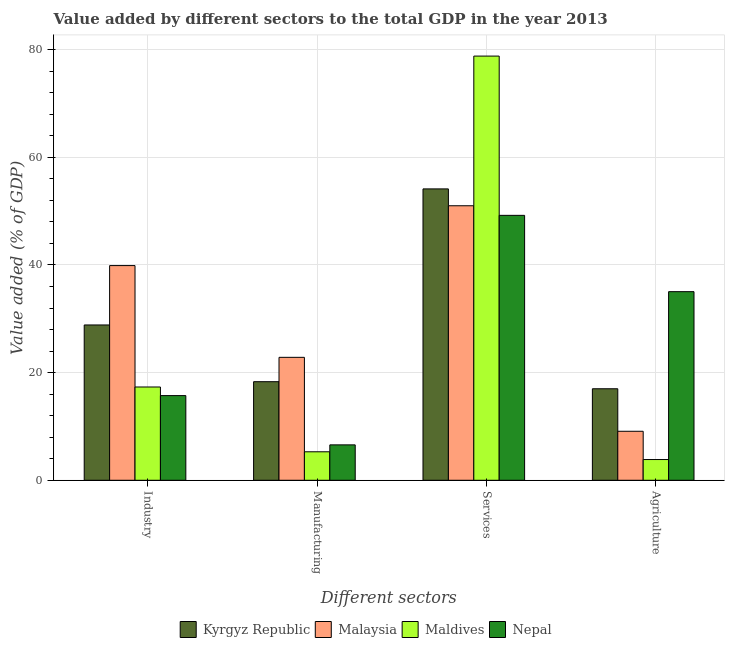How many groups of bars are there?
Provide a short and direct response. 4. Are the number of bars on each tick of the X-axis equal?
Give a very brief answer. Yes. What is the label of the 1st group of bars from the left?
Make the answer very short. Industry. What is the value added by services sector in Maldives?
Provide a succinct answer. 78.82. Across all countries, what is the maximum value added by industrial sector?
Your answer should be compact. 39.89. Across all countries, what is the minimum value added by industrial sector?
Offer a terse response. 15.73. In which country was the value added by agricultural sector maximum?
Your answer should be compact. Nepal. In which country was the value added by agricultural sector minimum?
Your response must be concise. Maldives. What is the total value added by industrial sector in the graph?
Provide a succinct answer. 101.81. What is the difference between the value added by services sector in Maldives and that in Nepal?
Offer a terse response. 29.59. What is the difference between the value added by industrial sector in Maldives and the value added by services sector in Nepal?
Your answer should be very brief. -31.89. What is the average value added by manufacturing sector per country?
Offer a very short reply. 13.26. What is the difference between the value added by industrial sector and value added by services sector in Maldives?
Give a very brief answer. -61.49. What is the ratio of the value added by services sector in Malaysia to that in Maldives?
Ensure brevity in your answer.  0.65. Is the difference between the value added by agricultural sector in Nepal and Malaysia greater than the difference between the value added by industrial sector in Nepal and Malaysia?
Give a very brief answer. Yes. What is the difference between the highest and the second highest value added by services sector?
Your answer should be compact. 24.68. What is the difference between the highest and the lowest value added by services sector?
Your answer should be very brief. 29.59. In how many countries, is the value added by industrial sector greater than the average value added by industrial sector taken over all countries?
Your answer should be compact. 2. Is it the case that in every country, the sum of the value added by agricultural sector and value added by manufacturing sector is greater than the sum of value added by industrial sector and value added by services sector?
Provide a short and direct response. No. What does the 2nd bar from the left in Industry represents?
Ensure brevity in your answer.  Malaysia. What does the 1st bar from the right in Services represents?
Give a very brief answer. Nepal. Is it the case that in every country, the sum of the value added by industrial sector and value added by manufacturing sector is greater than the value added by services sector?
Offer a very short reply. No. How many bars are there?
Your answer should be very brief. 16. Are all the bars in the graph horizontal?
Your answer should be very brief. No. How many countries are there in the graph?
Give a very brief answer. 4. What is the difference between two consecutive major ticks on the Y-axis?
Provide a succinct answer. 20. Are the values on the major ticks of Y-axis written in scientific E-notation?
Your response must be concise. No. Where does the legend appear in the graph?
Keep it short and to the point. Bottom center. How are the legend labels stacked?
Provide a short and direct response. Horizontal. What is the title of the graph?
Provide a short and direct response. Value added by different sectors to the total GDP in the year 2013. Does "South Sudan" appear as one of the legend labels in the graph?
Offer a terse response. No. What is the label or title of the X-axis?
Your response must be concise. Different sectors. What is the label or title of the Y-axis?
Make the answer very short. Value added (% of GDP). What is the Value added (% of GDP) of Kyrgyz Republic in Industry?
Offer a very short reply. 28.86. What is the Value added (% of GDP) of Malaysia in Industry?
Ensure brevity in your answer.  39.89. What is the Value added (% of GDP) in Maldives in Industry?
Your response must be concise. 17.33. What is the Value added (% of GDP) in Nepal in Industry?
Offer a very short reply. 15.73. What is the Value added (% of GDP) in Kyrgyz Republic in Manufacturing?
Your response must be concise. 18.32. What is the Value added (% of GDP) of Malaysia in Manufacturing?
Your answer should be compact. 22.84. What is the Value added (% of GDP) in Maldives in Manufacturing?
Your response must be concise. 5.29. What is the Value added (% of GDP) in Nepal in Manufacturing?
Provide a short and direct response. 6.58. What is the Value added (% of GDP) of Kyrgyz Republic in Services?
Give a very brief answer. 54.14. What is the Value added (% of GDP) in Malaysia in Services?
Offer a terse response. 51.01. What is the Value added (% of GDP) of Maldives in Services?
Keep it short and to the point. 78.82. What is the Value added (% of GDP) in Nepal in Services?
Provide a short and direct response. 49.22. What is the Value added (% of GDP) of Kyrgyz Republic in Agriculture?
Ensure brevity in your answer.  17. What is the Value added (% of GDP) of Malaysia in Agriculture?
Your response must be concise. 9.1. What is the Value added (% of GDP) of Maldives in Agriculture?
Ensure brevity in your answer.  3.85. What is the Value added (% of GDP) of Nepal in Agriculture?
Your answer should be compact. 35.05. Across all Different sectors, what is the maximum Value added (% of GDP) of Kyrgyz Republic?
Provide a short and direct response. 54.14. Across all Different sectors, what is the maximum Value added (% of GDP) in Malaysia?
Provide a succinct answer. 51.01. Across all Different sectors, what is the maximum Value added (% of GDP) in Maldives?
Provide a short and direct response. 78.82. Across all Different sectors, what is the maximum Value added (% of GDP) in Nepal?
Ensure brevity in your answer.  49.22. Across all Different sectors, what is the minimum Value added (% of GDP) in Kyrgyz Republic?
Offer a terse response. 17. Across all Different sectors, what is the minimum Value added (% of GDP) of Malaysia?
Provide a short and direct response. 9.1. Across all Different sectors, what is the minimum Value added (% of GDP) in Maldives?
Make the answer very short. 3.85. Across all Different sectors, what is the minimum Value added (% of GDP) in Nepal?
Give a very brief answer. 6.58. What is the total Value added (% of GDP) in Kyrgyz Republic in the graph?
Provide a succinct answer. 118.32. What is the total Value added (% of GDP) in Malaysia in the graph?
Provide a succinct answer. 122.84. What is the total Value added (% of GDP) in Maldives in the graph?
Keep it short and to the point. 105.29. What is the total Value added (% of GDP) of Nepal in the graph?
Your answer should be very brief. 106.58. What is the difference between the Value added (% of GDP) in Kyrgyz Republic in Industry and that in Manufacturing?
Make the answer very short. 10.54. What is the difference between the Value added (% of GDP) of Malaysia in Industry and that in Manufacturing?
Provide a succinct answer. 17.05. What is the difference between the Value added (% of GDP) of Maldives in Industry and that in Manufacturing?
Your response must be concise. 12.04. What is the difference between the Value added (% of GDP) of Nepal in Industry and that in Manufacturing?
Offer a terse response. 9.15. What is the difference between the Value added (% of GDP) of Kyrgyz Republic in Industry and that in Services?
Give a very brief answer. -25.28. What is the difference between the Value added (% of GDP) of Malaysia in Industry and that in Services?
Your response must be concise. -11.12. What is the difference between the Value added (% of GDP) of Maldives in Industry and that in Services?
Your answer should be very brief. -61.49. What is the difference between the Value added (% of GDP) in Nepal in Industry and that in Services?
Provide a succinct answer. -33.49. What is the difference between the Value added (% of GDP) of Kyrgyz Republic in Industry and that in Agriculture?
Your response must be concise. 11.85. What is the difference between the Value added (% of GDP) of Malaysia in Industry and that in Agriculture?
Offer a very short reply. 30.78. What is the difference between the Value added (% of GDP) of Maldives in Industry and that in Agriculture?
Keep it short and to the point. 13.48. What is the difference between the Value added (% of GDP) of Nepal in Industry and that in Agriculture?
Provide a short and direct response. -19.31. What is the difference between the Value added (% of GDP) of Kyrgyz Republic in Manufacturing and that in Services?
Make the answer very short. -35.82. What is the difference between the Value added (% of GDP) of Malaysia in Manufacturing and that in Services?
Your answer should be compact. -28.17. What is the difference between the Value added (% of GDP) in Maldives in Manufacturing and that in Services?
Offer a very short reply. -73.53. What is the difference between the Value added (% of GDP) of Nepal in Manufacturing and that in Services?
Make the answer very short. -42.65. What is the difference between the Value added (% of GDP) of Kyrgyz Republic in Manufacturing and that in Agriculture?
Give a very brief answer. 1.31. What is the difference between the Value added (% of GDP) of Malaysia in Manufacturing and that in Agriculture?
Offer a very short reply. 13.74. What is the difference between the Value added (% of GDP) of Maldives in Manufacturing and that in Agriculture?
Provide a short and direct response. 1.44. What is the difference between the Value added (% of GDP) in Nepal in Manufacturing and that in Agriculture?
Your answer should be very brief. -28.47. What is the difference between the Value added (% of GDP) of Kyrgyz Republic in Services and that in Agriculture?
Your response must be concise. 37.14. What is the difference between the Value added (% of GDP) of Malaysia in Services and that in Agriculture?
Offer a terse response. 41.9. What is the difference between the Value added (% of GDP) of Maldives in Services and that in Agriculture?
Ensure brevity in your answer.  74.97. What is the difference between the Value added (% of GDP) in Nepal in Services and that in Agriculture?
Your response must be concise. 14.18. What is the difference between the Value added (% of GDP) of Kyrgyz Republic in Industry and the Value added (% of GDP) of Malaysia in Manufacturing?
Ensure brevity in your answer.  6.01. What is the difference between the Value added (% of GDP) of Kyrgyz Republic in Industry and the Value added (% of GDP) of Maldives in Manufacturing?
Offer a very short reply. 23.57. What is the difference between the Value added (% of GDP) of Kyrgyz Republic in Industry and the Value added (% of GDP) of Nepal in Manufacturing?
Offer a terse response. 22.28. What is the difference between the Value added (% of GDP) of Malaysia in Industry and the Value added (% of GDP) of Maldives in Manufacturing?
Ensure brevity in your answer.  34.6. What is the difference between the Value added (% of GDP) in Malaysia in Industry and the Value added (% of GDP) in Nepal in Manufacturing?
Provide a short and direct response. 33.31. What is the difference between the Value added (% of GDP) in Maldives in Industry and the Value added (% of GDP) in Nepal in Manufacturing?
Offer a terse response. 10.75. What is the difference between the Value added (% of GDP) in Kyrgyz Republic in Industry and the Value added (% of GDP) in Malaysia in Services?
Make the answer very short. -22.15. What is the difference between the Value added (% of GDP) in Kyrgyz Republic in Industry and the Value added (% of GDP) in Maldives in Services?
Offer a terse response. -49.96. What is the difference between the Value added (% of GDP) in Kyrgyz Republic in Industry and the Value added (% of GDP) in Nepal in Services?
Ensure brevity in your answer.  -20.37. What is the difference between the Value added (% of GDP) of Malaysia in Industry and the Value added (% of GDP) of Maldives in Services?
Ensure brevity in your answer.  -38.93. What is the difference between the Value added (% of GDP) in Malaysia in Industry and the Value added (% of GDP) in Nepal in Services?
Your response must be concise. -9.34. What is the difference between the Value added (% of GDP) in Maldives in Industry and the Value added (% of GDP) in Nepal in Services?
Offer a terse response. -31.89. What is the difference between the Value added (% of GDP) of Kyrgyz Republic in Industry and the Value added (% of GDP) of Malaysia in Agriculture?
Ensure brevity in your answer.  19.75. What is the difference between the Value added (% of GDP) of Kyrgyz Republic in Industry and the Value added (% of GDP) of Maldives in Agriculture?
Offer a terse response. 25.01. What is the difference between the Value added (% of GDP) in Kyrgyz Republic in Industry and the Value added (% of GDP) in Nepal in Agriculture?
Keep it short and to the point. -6.19. What is the difference between the Value added (% of GDP) of Malaysia in Industry and the Value added (% of GDP) of Maldives in Agriculture?
Give a very brief answer. 36.04. What is the difference between the Value added (% of GDP) in Malaysia in Industry and the Value added (% of GDP) in Nepal in Agriculture?
Your answer should be very brief. 4.84. What is the difference between the Value added (% of GDP) in Maldives in Industry and the Value added (% of GDP) in Nepal in Agriculture?
Your answer should be compact. -17.71. What is the difference between the Value added (% of GDP) of Kyrgyz Republic in Manufacturing and the Value added (% of GDP) of Malaysia in Services?
Ensure brevity in your answer.  -32.69. What is the difference between the Value added (% of GDP) of Kyrgyz Republic in Manufacturing and the Value added (% of GDP) of Maldives in Services?
Your answer should be very brief. -60.5. What is the difference between the Value added (% of GDP) of Kyrgyz Republic in Manufacturing and the Value added (% of GDP) of Nepal in Services?
Provide a succinct answer. -30.91. What is the difference between the Value added (% of GDP) of Malaysia in Manufacturing and the Value added (% of GDP) of Maldives in Services?
Offer a terse response. -55.98. What is the difference between the Value added (% of GDP) of Malaysia in Manufacturing and the Value added (% of GDP) of Nepal in Services?
Offer a terse response. -26.38. What is the difference between the Value added (% of GDP) in Maldives in Manufacturing and the Value added (% of GDP) in Nepal in Services?
Provide a succinct answer. -43.93. What is the difference between the Value added (% of GDP) in Kyrgyz Republic in Manufacturing and the Value added (% of GDP) in Malaysia in Agriculture?
Give a very brief answer. 9.21. What is the difference between the Value added (% of GDP) of Kyrgyz Republic in Manufacturing and the Value added (% of GDP) of Maldives in Agriculture?
Your answer should be compact. 14.46. What is the difference between the Value added (% of GDP) of Kyrgyz Republic in Manufacturing and the Value added (% of GDP) of Nepal in Agriculture?
Make the answer very short. -16.73. What is the difference between the Value added (% of GDP) of Malaysia in Manufacturing and the Value added (% of GDP) of Maldives in Agriculture?
Your response must be concise. 18.99. What is the difference between the Value added (% of GDP) of Malaysia in Manufacturing and the Value added (% of GDP) of Nepal in Agriculture?
Offer a terse response. -12.2. What is the difference between the Value added (% of GDP) of Maldives in Manufacturing and the Value added (% of GDP) of Nepal in Agriculture?
Provide a succinct answer. -29.75. What is the difference between the Value added (% of GDP) in Kyrgyz Republic in Services and the Value added (% of GDP) in Malaysia in Agriculture?
Offer a very short reply. 45.04. What is the difference between the Value added (% of GDP) in Kyrgyz Republic in Services and the Value added (% of GDP) in Maldives in Agriculture?
Keep it short and to the point. 50.29. What is the difference between the Value added (% of GDP) in Kyrgyz Republic in Services and the Value added (% of GDP) in Nepal in Agriculture?
Ensure brevity in your answer.  19.1. What is the difference between the Value added (% of GDP) of Malaysia in Services and the Value added (% of GDP) of Maldives in Agriculture?
Offer a terse response. 47.16. What is the difference between the Value added (% of GDP) of Malaysia in Services and the Value added (% of GDP) of Nepal in Agriculture?
Provide a short and direct response. 15.96. What is the difference between the Value added (% of GDP) of Maldives in Services and the Value added (% of GDP) of Nepal in Agriculture?
Ensure brevity in your answer.  43.77. What is the average Value added (% of GDP) of Kyrgyz Republic per Different sectors?
Make the answer very short. 29.58. What is the average Value added (% of GDP) in Malaysia per Different sectors?
Keep it short and to the point. 30.71. What is the average Value added (% of GDP) in Maldives per Different sectors?
Provide a short and direct response. 26.32. What is the average Value added (% of GDP) of Nepal per Different sectors?
Make the answer very short. 26.64. What is the difference between the Value added (% of GDP) in Kyrgyz Republic and Value added (% of GDP) in Malaysia in Industry?
Make the answer very short. -11.03. What is the difference between the Value added (% of GDP) in Kyrgyz Republic and Value added (% of GDP) in Maldives in Industry?
Offer a terse response. 11.53. What is the difference between the Value added (% of GDP) in Kyrgyz Republic and Value added (% of GDP) in Nepal in Industry?
Provide a succinct answer. 13.13. What is the difference between the Value added (% of GDP) in Malaysia and Value added (% of GDP) in Maldives in Industry?
Keep it short and to the point. 22.56. What is the difference between the Value added (% of GDP) of Malaysia and Value added (% of GDP) of Nepal in Industry?
Make the answer very short. 24.16. What is the difference between the Value added (% of GDP) of Maldives and Value added (% of GDP) of Nepal in Industry?
Your answer should be compact. 1.6. What is the difference between the Value added (% of GDP) of Kyrgyz Republic and Value added (% of GDP) of Malaysia in Manufacturing?
Offer a very short reply. -4.53. What is the difference between the Value added (% of GDP) of Kyrgyz Republic and Value added (% of GDP) of Maldives in Manufacturing?
Your response must be concise. 13.02. What is the difference between the Value added (% of GDP) of Kyrgyz Republic and Value added (% of GDP) of Nepal in Manufacturing?
Your answer should be very brief. 11.74. What is the difference between the Value added (% of GDP) of Malaysia and Value added (% of GDP) of Maldives in Manufacturing?
Your response must be concise. 17.55. What is the difference between the Value added (% of GDP) in Malaysia and Value added (% of GDP) in Nepal in Manufacturing?
Your answer should be compact. 16.27. What is the difference between the Value added (% of GDP) of Maldives and Value added (% of GDP) of Nepal in Manufacturing?
Keep it short and to the point. -1.29. What is the difference between the Value added (% of GDP) of Kyrgyz Republic and Value added (% of GDP) of Malaysia in Services?
Ensure brevity in your answer.  3.13. What is the difference between the Value added (% of GDP) in Kyrgyz Republic and Value added (% of GDP) in Maldives in Services?
Make the answer very short. -24.68. What is the difference between the Value added (% of GDP) in Kyrgyz Republic and Value added (% of GDP) in Nepal in Services?
Give a very brief answer. 4.92. What is the difference between the Value added (% of GDP) of Malaysia and Value added (% of GDP) of Maldives in Services?
Your answer should be very brief. -27.81. What is the difference between the Value added (% of GDP) in Malaysia and Value added (% of GDP) in Nepal in Services?
Offer a terse response. 1.78. What is the difference between the Value added (% of GDP) of Maldives and Value added (% of GDP) of Nepal in Services?
Offer a very short reply. 29.59. What is the difference between the Value added (% of GDP) in Kyrgyz Republic and Value added (% of GDP) in Malaysia in Agriculture?
Ensure brevity in your answer.  7.9. What is the difference between the Value added (% of GDP) of Kyrgyz Republic and Value added (% of GDP) of Maldives in Agriculture?
Give a very brief answer. 13.15. What is the difference between the Value added (% of GDP) in Kyrgyz Republic and Value added (% of GDP) in Nepal in Agriculture?
Keep it short and to the point. -18.04. What is the difference between the Value added (% of GDP) in Malaysia and Value added (% of GDP) in Maldives in Agriculture?
Keep it short and to the point. 5.25. What is the difference between the Value added (% of GDP) in Malaysia and Value added (% of GDP) in Nepal in Agriculture?
Offer a very short reply. -25.94. What is the difference between the Value added (% of GDP) of Maldives and Value added (% of GDP) of Nepal in Agriculture?
Keep it short and to the point. -31.19. What is the ratio of the Value added (% of GDP) in Kyrgyz Republic in Industry to that in Manufacturing?
Your answer should be very brief. 1.58. What is the ratio of the Value added (% of GDP) in Malaysia in Industry to that in Manufacturing?
Ensure brevity in your answer.  1.75. What is the ratio of the Value added (% of GDP) of Maldives in Industry to that in Manufacturing?
Offer a very short reply. 3.28. What is the ratio of the Value added (% of GDP) in Nepal in Industry to that in Manufacturing?
Offer a very short reply. 2.39. What is the ratio of the Value added (% of GDP) in Kyrgyz Republic in Industry to that in Services?
Provide a succinct answer. 0.53. What is the ratio of the Value added (% of GDP) in Malaysia in Industry to that in Services?
Keep it short and to the point. 0.78. What is the ratio of the Value added (% of GDP) of Maldives in Industry to that in Services?
Your response must be concise. 0.22. What is the ratio of the Value added (% of GDP) in Nepal in Industry to that in Services?
Your answer should be compact. 0.32. What is the ratio of the Value added (% of GDP) in Kyrgyz Republic in Industry to that in Agriculture?
Provide a succinct answer. 1.7. What is the ratio of the Value added (% of GDP) of Malaysia in Industry to that in Agriculture?
Keep it short and to the point. 4.38. What is the ratio of the Value added (% of GDP) in Nepal in Industry to that in Agriculture?
Provide a short and direct response. 0.45. What is the ratio of the Value added (% of GDP) in Kyrgyz Republic in Manufacturing to that in Services?
Provide a succinct answer. 0.34. What is the ratio of the Value added (% of GDP) of Malaysia in Manufacturing to that in Services?
Provide a short and direct response. 0.45. What is the ratio of the Value added (% of GDP) in Maldives in Manufacturing to that in Services?
Ensure brevity in your answer.  0.07. What is the ratio of the Value added (% of GDP) of Nepal in Manufacturing to that in Services?
Provide a short and direct response. 0.13. What is the ratio of the Value added (% of GDP) of Kyrgyz Republic in Manufacturing to that in Agriculture?
Provide a succinct answer. 1.08. What is the ratio of the Value added (% of GDP) of Malaysia in Manufacturing to that in Agriculture?
Offer a very short reply. 2.51. What is the ratio of the Value added (% of GDP) of Maldives in Manufacturing to that in Agriculture?
Provide a succinct answer. 1.37. What is the ratio of the Value added (% of GDP) of Nepal in Manufacturing to that in Agriculture?
Offer a very short reply. 0.19. What is the ratio of the Value added (% of GDP) in Kyrgyz Republic in Services to that in Agriculture?
Your answer should be compact. 3.18. What is the ratio of the Value added (% of GDP) of Malaysia in Services to that in Agriculture?
Offer a very short reply. 5.6. What is the ratio of the Value added (% of GDP) in Maldives in Services to that in Agriculture?
Make the answer very short. 20.46. What is the ratio of the Value added (% of GDP) in Nepal in Services to that in Agriculture?
Your answer should be very brief. 1.4. What is the difference between the highest and the second highest Value added (% of GDP) of Kyrgyz Republic?
Provide a succinct answer. 25.28. What is the difference between the highest and the second highest Value added (% of GDP) of Malaysia?
Your answer should be compact. 11.12. What is the difference between the highest and the second highest Value added (% of GDP) of Maldives?
Your answer should be compact. 61.49. What is the difference between the highest and the second highest Value added (% of GDP) in Nepal?
Give a very brief answer. 14.18. What is the difference between the highest and the lowest Value added (% of GDP) in Kyrgyz Republic?
Give a very brief answer. 37.14. What is the difference between the highest and the lowest Value added (% of GDP) in Malaysia?
Ensure brevity in your answer.  41.9. What is the difference between the highest and the lowest Value added (% of GDP) of Maldives?
Provide a succinct answer. 74.97. What is the difference between the highest and the lowest Value added (% of GDP) of Nepal?
Give a very brief answer. 42.65. 